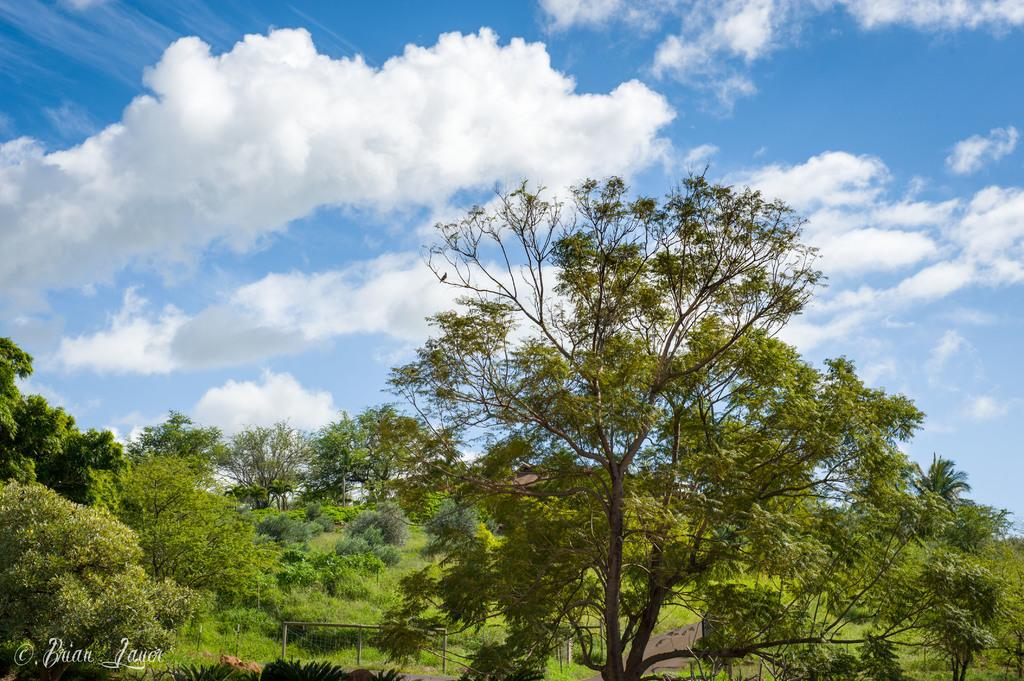What type of vegetation can be seen in the image? There are plants and trees in the image. What is visible at the top of the image? The sky is visible at the top of the image. Can you describe any text present in the image? Yes, there is text on the bottom left of the image. What type of skirt is the clam wearing in the image? There is no clam or skirt present in the image. Can you hear the voice of the person speaking in the image? There is no audio or voice present in the image, as it is a still image. 